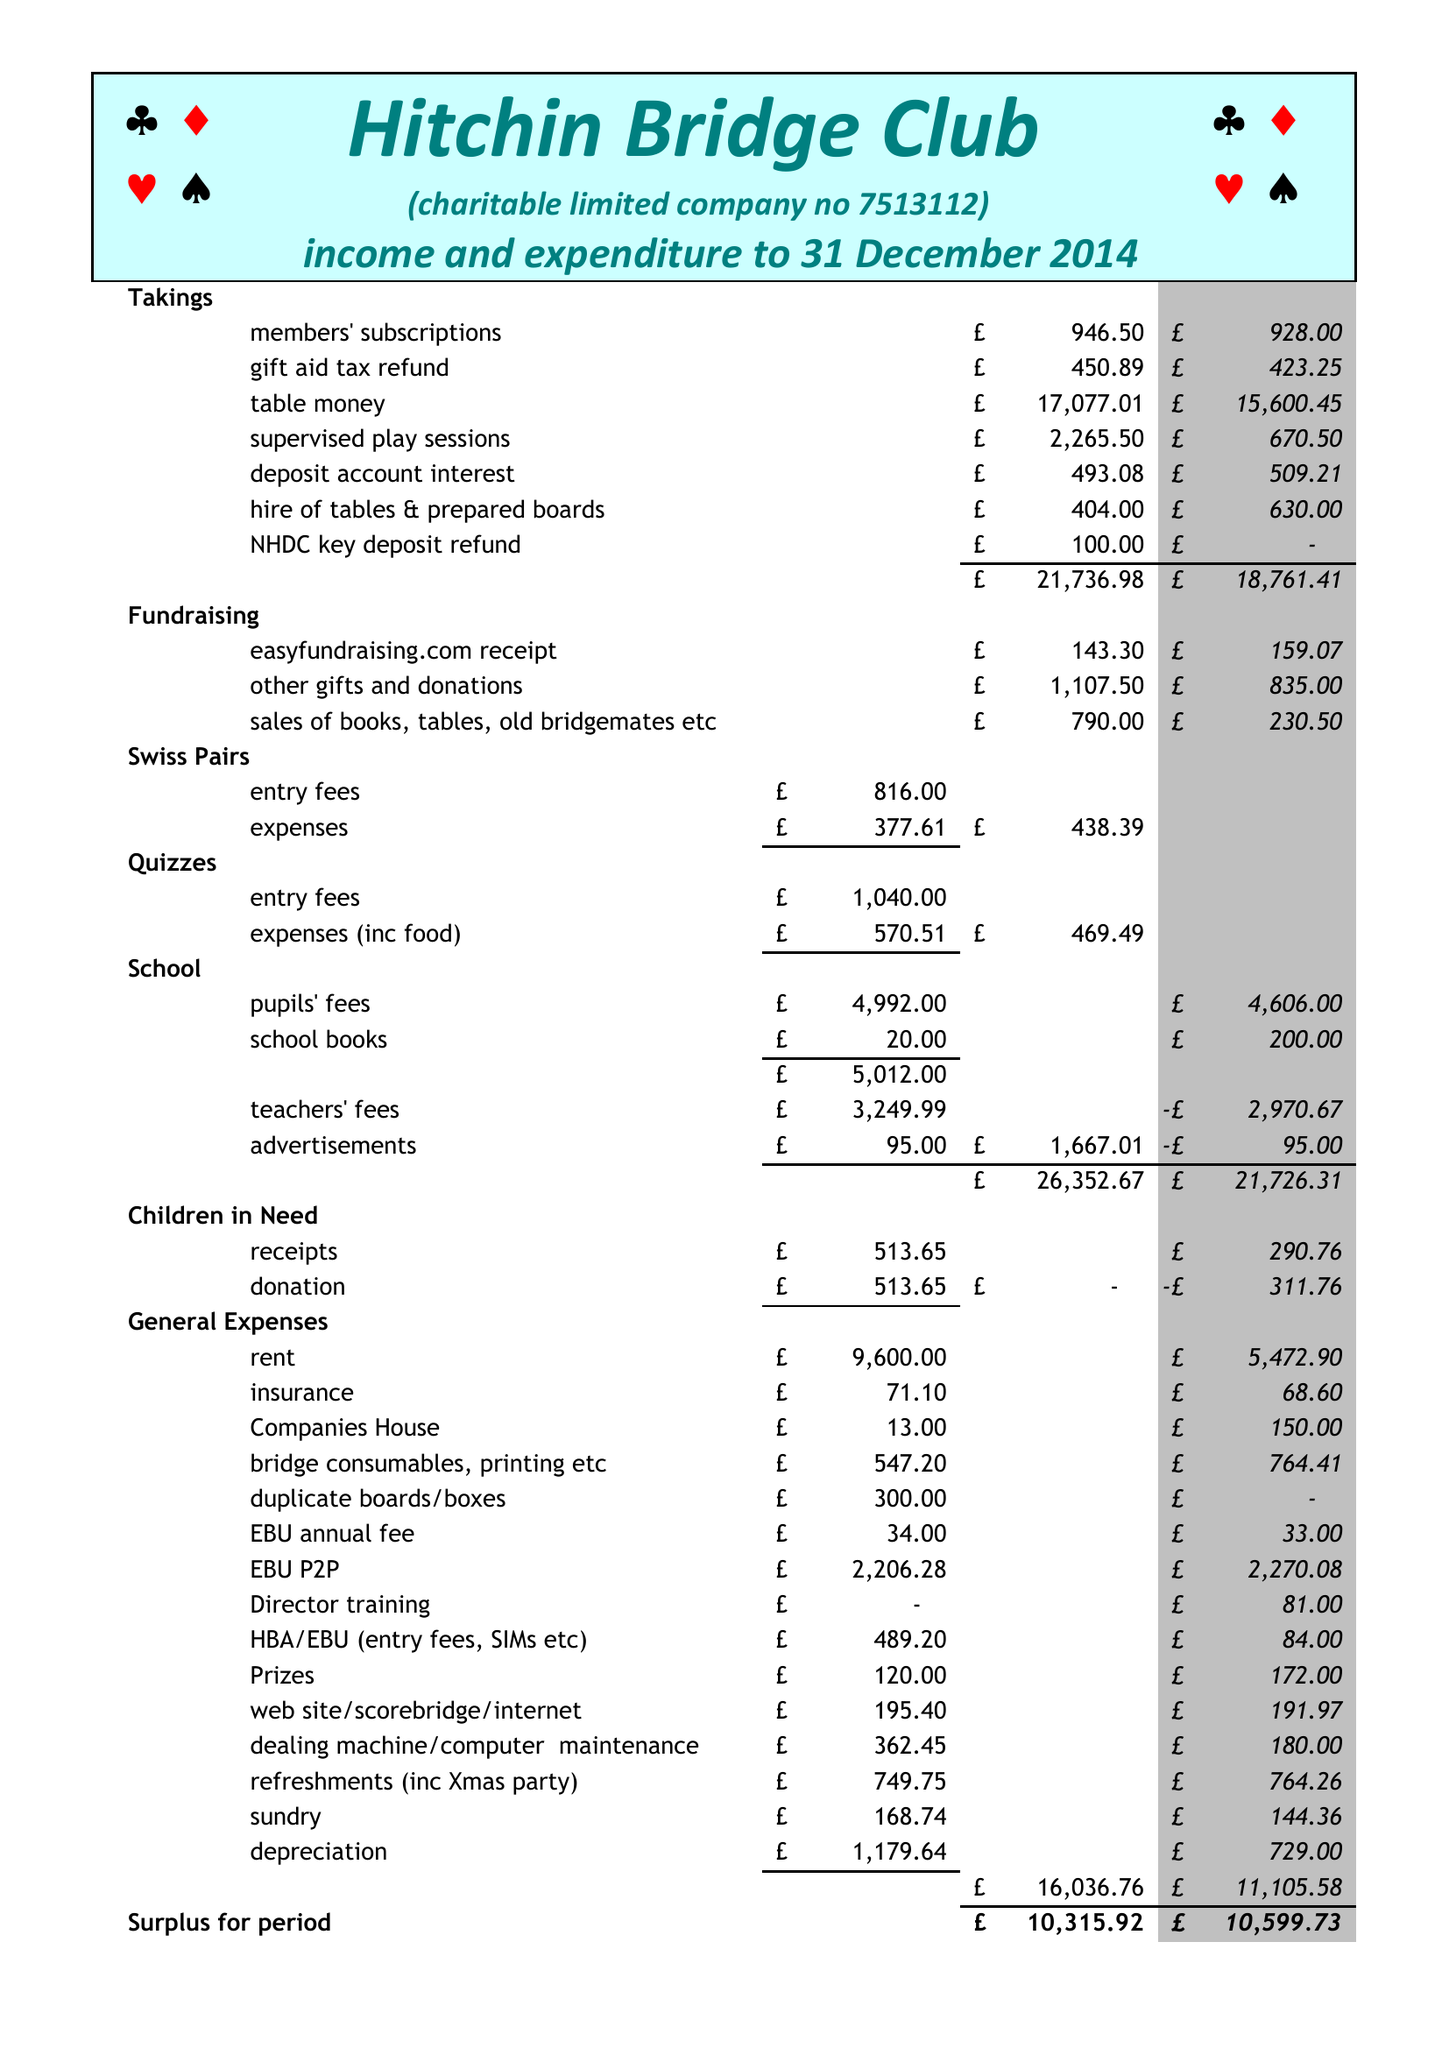What is the value for the address__postcode?
Answer the question using a single word or phrase. SG5 2HZ 